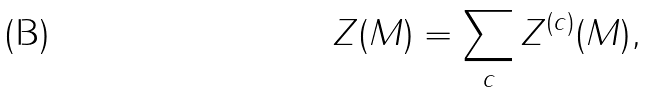Convert formula to latex. <formula><loc_0><loc_0><loc_500><loc_500>Z ( M ) = \sum _ { c } Z ^ { ( c ) } ( M ) ,</formula> 